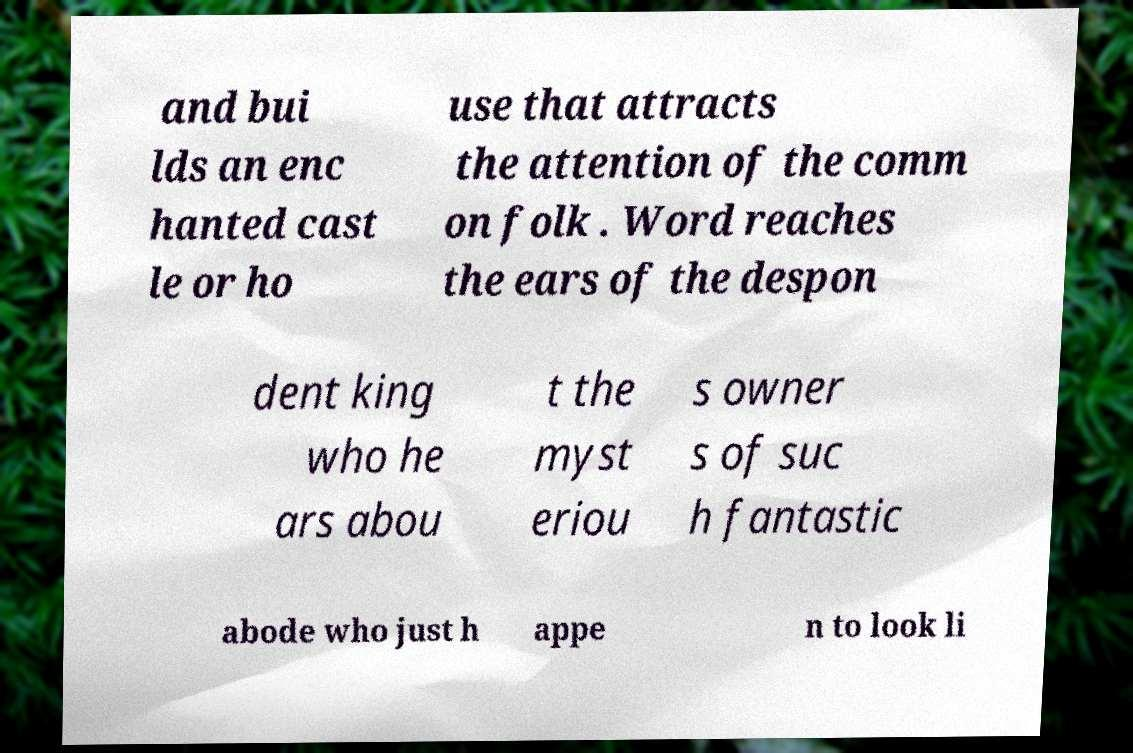What messages or text are displayed in this image? I need them in a readable, typed format. and bui lds an enc hanted cast le or ho use that attracts the attention of the comm on folk . Word reaches the ears of the despon dent king who he ars abou t the myst eriou s owner s of suc h fantastic abode who just h appe n to look li 